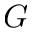<formula> <loc_0><loc_0><loc_500><loc_500>G</formula> 